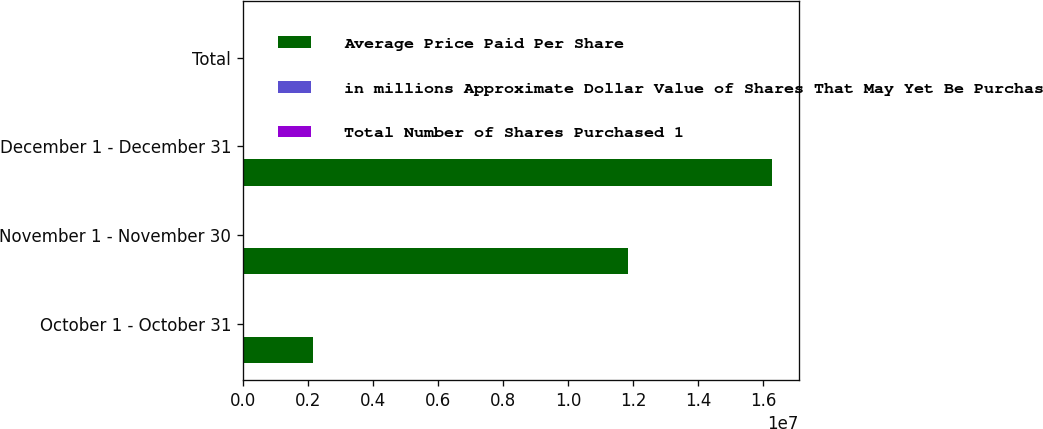Convert chart to OTSL. <chart><loc_0><loc_0><loc_500><loc_500><stacked_bar_chart><ecel><fcel>October 1 - October 31<fcel>November 1 - November 30<fcel>December 1 - December 31<fcel>Total<nl><fcel>Average Price Paid Per Share<fcel>2.17234e+06<fcel>1.18503e+07<fcel>1.6285e+07<fcel>2605<nl><fcel>in millions Approximate Dollar Value of Shares That May Yet Be Purchased Under the Plans or Programs 1<fcel>63.38<fcel>55.03<fcel>56.05<fcel>56.17<nl><fcel>Total Number of Shares Purchased 1<fcel>2605<fcel>1953<fcel>11040<fcel>11040<nl></chart> 